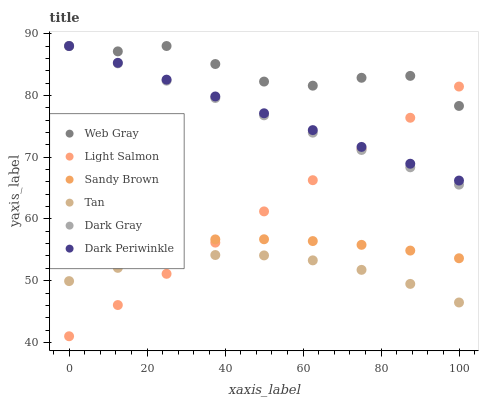Does Tan have the minimum area under the curve?
Answer yes or no. Yes. Does Web Gray have the maximum area under the curve?
Answer yes or no. Yes. Does Dark Gray have the minimum area under the curve?
Answer yes or no. No. Does Dark Gray have the maximum area under the curve?
Answer yes or no. No. Is Light Salmon the smoothest?
Answer yes or no. Yes. Is Web Gray the roughest?
Answer yes or no. Yes. Is Dark Gray the smoothest?
Answer yes or no. No. Is Dark Gray the roughest?
Answer yes or no. No. Does Light Salmon have the lowest value?
Answer yes or no. Yes. Does Dark Gray have the lowest value?
Answer yes or no. No. Does Dark Periwinkle have the highest value?
Answer yes or no. Yes. Does Tan have the highest value?
Answer yes or no. No. Is Tan less than Dark Periwinkle?
Answer yes or no. Yes. Is Web Gray greater than Sandy Brown?
Answer yes or no. Yes. Does Dark Periwinkle intersect Light Salmon?
Answer yes or no. Yes. Is Dark Periwinkle less than Light Salmon?
Answer yes or no. No. Is Dark Periwinkle greater than Light Salmon?
Answer yes or no. No. Does Tan intersect Dark Periwinkle?
Answer yes or no. No. 